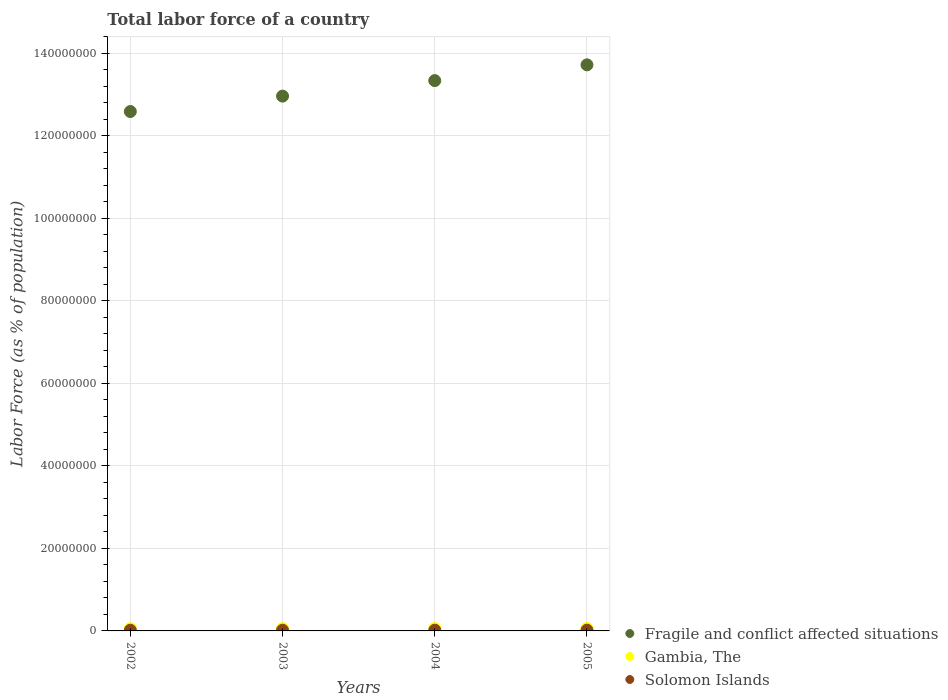How many different coloured dotlines are there?
Provide a succinct answer. 3. What is the percentage of labor force in Gambia, The in 2003?
Offer a terse response. 5.63e+05. Across all years, what is the maximum percentage of labor force in Gambia, The?
Your answer should be very brief. 6.01e+05. Across all years, what is the minimum percentage of labor force in Gambia, The?
Offer a terse response. 5.46e+05. What is the total percentage of labor force in Solomon Islands in the graph?
Your answer should be very brief. 7.03e+05. What is the difference between the percentage of labor force in Solomon Islands in 2002 and that in 2005?
Your answer should be very brief. -1.50e+04. What is the difference between the percentage of labor force in Fragile and conflict affected situations in 2003 and the percentage of labor force in Gambia, The in 2005?
Give a very brief answer. 1.29e+08. What is the average percentage of labor force in Gambia, The per year?
Keep it short and to the point. 5.73e+05. In the year 2002, what is the difference between the percentage of labor force in Solomon Islands and percentage of labor force in Fragile and conflict affected situations?
Your answer should be compact. -1.26e+08. What is the ratio of the percentage of labor force in Fragile and conflict affected situations in 2002 to that in 2003?
Offer a terse response. 0.97. Is the difference between the percentage of labor force in Solomon Islands in 2002 and 2003 greater than the difference between the percentage of labor force in Fragile and conflict affected situations in 2002 and 2003?
Ensure brevity in your answer.  Yes. What is the difference between the highest and the second highest percentage of labor force in Gambia, The?
Provide a short and direct response. 1.98e+04. What is the difference between the highest and the lowest percentage of labor force in Fragile and conflict affected situations?
Your answer should be very brief. 1.13e+07. Is the sum of the percentage of labor force in Fragile and conflict affected situations in 2003 and 2005 greater than the maximum percentage of labor force in Gambia, The across all years?
Offer a very short reply. Yes. Is it the case that in every year, the sum of the percentage of labor force in Solomon Islands and percentage of labor force in Fragile and conflict affected situations  is greater than the percentage of labor force in Gambia, The?
Offer a terse response. Yes. How many dotlines are there?
Give a very brief answer. 3. Are the values on the major ticks of Y-axis written in scientific E-notation?
Keep it short and to the point. No. Does the graph contain any zero values?
Provide a succinct answer. No. Where does the legend appear in the graph?
Your response must be concise. Bottom right. How are the legend labels stacked?
Your answer should be very brief. Vertical. What is the title of the graph?
Provide a succinct answer. Total labor force of a country. Does "United States" appear as one of the legend labels in the graph?
Offer a terse response. No. What is the label or title of the X-axis?
Keep it short and to the point. Years. What is the label or title of the Y-axis?
Offer a very short reply. Labor Force (as % of population). What is the Labor Force (as % of population) of Fragile and conflict affected situations in 2002?
Offer a very short reply. 1.26e+08. What is the Labor Force (as % of population) in Gambia, The in 2002?
Ensure brevity in your answer.  5.46e+05. What is the Labor Force (as % of population) of Solomon Islands in 2002?
Provide a succinct answer. 1.68e+05. What is the Labor Force (as % of population) in Fragile and conflict affected situations in 2003?
Give a very brief answer. 1.30e+08. What is the Labor Force (as % of population) of Gambia, The in 2003?
Your answer should be very brief. 5.63e+05. What is the Labor Force (as % of population) in Solomon Islands in 2003?
Give a very brief answer. 1.73e+05. What is the Labor Force (as % of population) of Fragile and conflict affected situations in 2004?
Your answer should be very brief. 1.33e+08. What is the Labor Force (as % of population) in Gambia, The in 2004?
Give a very brief answer. 5.81e+05. What is the Labor Force (as % of population) in Solomon Islands in 2004?
Keep it short and to the point. 1.78e+05. What is the Labor Force (as % of population) in Fragile and conflict affected situations in 2005?
Your response must be concise. 1.37e+08. What is the Labor Force (as % of population) in Gambia, The in 2005?
Give a very brief answer. 6.01e+05. What is the Labor Force (as % of population) in Solomon Islands in 2005?
Give a very brief answer. 1.83e+05. Across all years, what is the maximum Labor Force (as % of population) in Fragile and conflict affected situations?
Keep it short and to the point. 1.37e+08. Across all years, what is the maximum Labor Force (as % of population) in Gambia, The?
Your response must be concise. 6.01e+05. Across all years, what is the maximum Labor Force (as % of population) of Solomon Islands?
Keep it short and to the point. 1.83e+05. Across all years, what is the minimum Labor Force (as % of population) in Fragile and conflict affected situations?
Your answer should be compact. 1.26e+08. Across all years, what is the minimum Labor Force (as % of population) in Gambia, The?
Ensure brevity in your answer.  5.46e+05. Across all years, what is the minimum Labor Force (as % of population) in Solomon Islands?
Provide a short and direct response. 1.68e+05. What is the total Labor Force (as % of population) of Fragile and conflict affected situations in the graph?
Your response must be concise. 5.26e+08. What is the total Labor Force (as % of population) in Gambia, The in the graph?
Offer a very short reply. 2.29e+06. What is the total Labor Force (as % of population) in Solomon Islands in the graph?
Your response must be concise. 7.03e+05. What is the difference between the Labor Force (as % of population) in Fragile and conflict affected situations in 2002 and that in 2003?
Provide a short and direct response. -3.74e+06. What is the difference between the Labor Force (as % of population) of Gambia, The in 2002 and that in 2003?
Provide a succinct answer. -1.73e+04. What is the difference between the Labor Force (as % of population) in Solomon Islands in 2002 and that in 2003?
Your answer should be compact. -4986. What is the difference between the Labor Force (as % of population) in Fragile and conflict affected situations in 2002 and that in 2004?
Your answer should be compact. -7.50e+06. What is the difference between the Labor Force (as % of population) in Gambia, The in 2002 and that in 2004?
Ensure brevity in your answer.  -3.56e+04. What is the difference between the Labor Force (as % of population) of Solomon Islands in 2002 and that in 2004?
Give a very brief answer. -1.01e+04. What is the difference between the Labor Force (as % of population) of Fragile and conflict affected situations in 2002 and that in 2005?
Your response must be concise. -1.13e+07. What is the difference between the Labor Force (as % of population) of Gambia, The in 2002 and that in 2005?
Give a very brief answer. -5.54e+04. What is the difference between the Labor Force (as % of population) of Solomon Islands in 2002 and that in 2005?
Your answer should be very brief. -1.50e+04. What is the difference between the Labor Force (as % of population) of Fragile and conflict affected situations in 2003 and that in 2004?
Provide a succinct answer. -3.76e+06. What is the difference between the Labor Force (as % of population) of Gambia, The in 2003 and that in 2004?
Give a very brief answer. -1.83e+04. What is the difference between the Labor Force (as % of population) of Solomon Islands in 2003 and that in 2004?
Ensure brevity in your answer.  -5071. What is the difference between the Labor Force (as % of population) of Fragile and conflict affected situations in 2003 and that in 2005?
Offer a terse response. -7.58e+06. What is the difference between the Labor Force (as % of population) in Gambia, The in 2003 and that in 2005?
Your answer should be very brief. -3.81e+04. What is the difference between the Labor Force (as % of population) of Solomon Islands in 2003 and that in 2005?
Offer a very short reply. -9994. What is the difference between the Labor Force (as % of population) in Fragile and conflict affected situations in 2004 and that in 2005?
Make the answer very short. -3.82e+06. What is the difference between the Labor Force (as % of population) of Gambia, The in 2004 and that in 2005?
Your answer should be very brief. -1.98e+04. What is the difference between the Labor Force (as % of population) of Solomon Islands in 2004 and that in 2005?
Provide a succinct answer. -4923. What is the difference between the Labor Force (as % of population) in Fragile and conflict affected situations in 2002 and the Labor Force (as % of population) in Gambia, The in 2003?
Provide a succinct answer. 1.25e+08. What is the difference between the Labor Force (as % of population) of Fragile and conflict affected situations in 2002 and the Labor Force (as % of population) of Solomon Islands in 2003?
Give a very brief answer. 1.26e+08. What is the difference between the Labor Force (as % of population) of Gambia, The in 2002 and the Labor Force (as % of population) of Solomon Islands in 2003?
Provide a short and direct response. 3.73e+05. What is the difference between the Labor Force (as % of population) in Fragile and conflict affected situations in 2002 and the Labor Force (as % of population) in Gambia, The in 2004?
Provide a succinct answer. 1.25e+08. What is the difference between the Labor Force (as % of population) of Fragile and conflict affected situations in 2002 and the Labor Force (as % of population) of Solomon Islands in 2004?
Provide a succinct answer. 1.26e+08. What is the difference between the Labor Force (as % of population) of Gambia, The in 2002 and the Labor Force (as % of population) of Solomon Islands in 2004?
Make the answer very short. 3.67e+05. What is the difference between the Labor Force (as % of population) in Fragile and conflict affected situations in 2002 and the Labor Force (as % of population) in Gambia, The in 2005?
Offer a terse response. 1.25e+08. What is the difference between the Labor Force (as % of population) of Fragile and conflict affected situations in 2002 and the Labor Force (as % of population) of Solomon Islands in 2005?
Provide a short and direct response. 1.26e+08. What is the difference between the Labor Force (as % of population) of Gambia, The in 2002 and the Labor Force (as % of population) of Solomon Islands in 2005?
Your response must be concise. 3.63e+05. What is the difference between the Labor Force (as % of population) in Fragile and conflict affected situations in 2003 and the Labor Force (as % of population) in Gambia, The in 2004?
Ensure brevity in your answer.  1.29e+08. What is the difference between the Labor Force (as % of population) in Fragile and conflict affected situations in 2003 and the Labor Force (as % of population) in Solomon Islands in 2004?
Give a very brief answer. 1.29e+08. What is the difference between the Labor Force (as % of population) in Gambia, The in 2003 and the Labor Force (as % of population) in Solomon Islands in 2004?
Provide a short and direct response. 3.85e+05. What is the difference between the Labor Force (as % of population) in Fragile and conflict affected situations in 2003 and the Labor Force (as % of population) in Gambia, The in 2005?
Your answer should be compact. 1.29e+08. What is the difference between the Labor Force (as % of population) in Fragile and conflict affected situations in 2003 and the Labor Force (as % of population) in Solomon Islands in 2005?
Keep it short and to the point. 1.29e+08. What is the difference between the Labor Force (as % of population) of Gambia, The in 2003 and the Labor Force (as % of population) of Solomon Islands in 2005?
Your answer should be very brief. 3.80e+05. What is the difference between the Labor Force (as % of population) in Fragile and conflict affected situations in 2004 and the Labor Force (as % of population) in Gambia, The in 2005?
Your response must be concise. 1.33e+08. What is the difference between the Labor Force (as % of population) in Fragile and conflict affected situations in 2004 and the Labor Force (as % of population) in Solomon Islands in 2005?
Keep it short and to the point. 1.33e+08. What is the difference between the Labor Force (as % of population) of Gambia, The in 2004 and the Labor Force (as % of population) of Solomon Islands in 2005?
Provide a succinct answer. 3.98e+05. What is the average Labor Force (as % of population) in Fragile and conflict affected situations per year?
Offer a very short reply. 1.32e+08. What is the average Labor Force (as % of population) in Gambia, The per year?
Your answer should be very brief. 5.73e+05. What is the average Labor Force (as % of population) in Solomon Islands per year?
Your response must be concise. 1.76e+05. In the year 2002, what is the difference between the Labor Force (as % of population) of Fragile and conflict affected situations and Labor Force (as % of population) of Gambia, The?
Your response must be concise. 1.25e+08. In the year 2002, what is the difference between the Labor Force (as % of population) in Fragile and conflict affected situations and Labor Force (as % of population) in Solomon Islands?
Make the answer very short. 1.26e+08. In the year 2002, what is the difference between the Labor Force (as % of population) of Gambia, The and Labor Force (as % of population) of Solomon Islands?
Make the answer very short. 3.78e+05. In the year 2003, what is the difference between the Labor Force (as % of population) in Fragile and conflict affected situations and Labor Force (as % of population) in Gambia, The?
Give a very brief answer. 1.29e+08. In the year 2003, what is the difference between the Labor Force (as % of population) of Fragile and conflict affected situations and Labor Force (as % of population) of Solomon Islands?
Give a very brief answer. 1.29e+08. In the year 2003, what is the difference between the Labor Force (as % of population) in Gambia, The and Labor Force (as % of population) in Solomon Islands?
Your answer should be very brief. 3.90e+05. In the year 2004, what is the difference between the Labor Force (as % of population) of Fragile and conflict affected situations and Labor Force (as % of population) of Gambia, The?
Offer a very short reply. 1.33e+08. In the year 2004, what is the difference between the Labor Force (as % of population) of Fragile and conflict affected situations and Labor Force (as % of population) of Solomon Islands?
Offer a terse response. 1.33e+08. In the year 2004, what is the difference between the Labor Force (as % of population) in Gambia, The and Labor Force (as % of population) in Solomon Islands?
Offer a very short reply. 4.03e+05. In the year 2005, what is the difference between the Labor Force (as % of population) of Fragile and conflict affected situations and Labor Force (as % of population) of Gambia, The?
Your answer should be compact. 1.37e+08. In the year 2005, what is the difference between the Labor Force (as % of population) of Fragile and conflict affected situations and Labor Force (as % of population) of Solomon Islands?
Keep it short and to the point. 1.37e+08. In the year 2005, what is the difference between the Labor Force (as % of population) of Gambia, The and Labor Force (as % of population) of Solomon Islands?
Your answer should be very brief. 4.18e+05. What is the ratio of the Labor Force (as % of population) in Fragile and conflict affected situations in 2002 to that in 2003?
Offer a terse response. 0.97. What is the ratio of the Labor Force (as % of population) in Gambia, The in 2002 to that in 2003?
Make the answer very short. 0.97. What is the ratio of the Labor Force (as % of population) in Solomon Islands in 2002 to that in 2003?
Your response must be concise. 0.97. What is the ratio of the Labor Force (as % of population) of Fragile and conflict affected situations in 2002 to that in 2004?
Your answer should be compact. 0.94. What is the ratio of the Labor Force (as % of population) in Gambia, The in 2002 to that in 2004?
Offer a terse response. 0.94. What is the ratio of the Labor Force (as % of population) of Solomon Islands in 2002 to that in 2004?
Your response must be concise. 0.94. What is the ratio of the Labor Force (as % of population) of Fragile and conflict affected situations in 2002 to that in 2005?
Keep it short and to the point. 0.92. What is the ratio of the Labor Force (as % of population) of Gambia, The in 2002 to that in 2005?
Ensure brevity in your answer.  0.91. What is the ratio of the Labor Force (as % of population) in Solomon Islands in 2002 to that in 2005?
Your response must be concise. 0.92. What is the ratio of the Labor Force (as % of population) in Fragile and conflict affected situations in 2003 to that in 2004?
Ensure brevity in your answer.  0.97. What is the ratio of the Labor Force (as % of population) of Gambia, The in 2003 to that in 2004?
Offer a terse response. 0.97. What is the ratio of the Labor Force (as % of population) in Solomon Islands in 2003 to that in 2004?
Your answer should be compact. 0.97. What is the ratio of the Labor Force (as % of population) in Fragile and conflict affected situations in 2003 to that in 2005?
Your answer should be compact. 0.94. What is the ratio of the Labor Force (as % of population) of Gambia, The in 2003 to that in 2005?
Ensure brevity in your answer.  0.94. What is the ratio of the Labor Force (as % of population) in Solomon Islands in 2003 to that in 2005?
Offer a terse response. 0.95. What is the ratio of the Labor Force (as % of population) in Fragile and conflict affected situations in 2004 to that in 2005?
Provide a succinct answer. 0.97. What is the ratio of the Labor Force (as % of population) in Solomon Islands in 2004 to that in 2005?
Offer a very short reply. 0.97. What is the difference between the highest and the second highest Labor Force (as % of population) in Fragile and conflict affected situations?
Your response must be concise. 3.82e+06. What is the difference between the highest and the second highest Labor Force (as % of population) in Gambia, The?
Make the answer very short. 1.98e+04. What is the difference between the highest and the second highest Labor Force (as % of population) in Solomon Islands?
Your answer should be compact. 4923. What is the difference between the highest and the lowest Labor Force (as % of population) in Fragile and conflict affected situations?
Provide a short and direct response. 1.13e+07. What is the difference between the highest and the lowest Labor Force (as % of population) in Gambia, The?
Ensure brevity in your answer.  5.54e+04. What is the difference between the highest and the lowest Labor Force (as % of population) in Solomon Islands?
Your answer should be compact. 1.50e+04. 